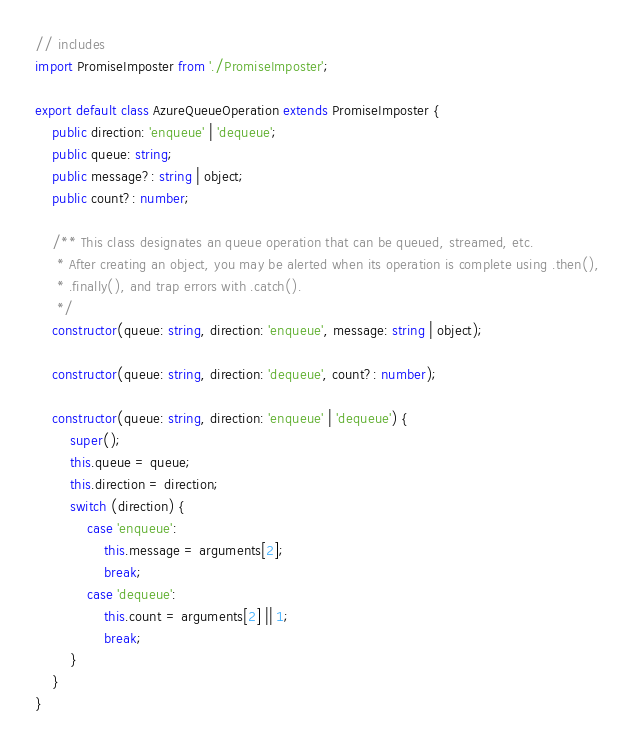<code> <loc_0><loc_0><loc_500><loc_500><_TypeScript_>// includes
import PromiseImposter from './PromiseImposter';

export default class AzureQueueOperation extends PromiseImposter {
    public direction: 'enqueue' | 'dequeue';
    public queue: string;
    public message?: string | object;
    public count?: number;

    /** This class designates an queue operation that can be queued, streamed, etc.
     * After creating an object, you may be alerted when its operation is complete using .then(),
     * .finally(), and trap errors with .catch().
     */
    constructor(queue: string, direction: 'enqueue', message: string | object);

    constructor(queue: string, direction: 'dequeue', count?: number);

    constructor(queue: string, direction: 'enqueue' | 'dequeue') {
        super();
        this.queue = queue;
        this.direction = direction;
        switch (direction) {
            case 'enqueue':
                this.message = arguments[2];
                break;
            case 'dequeue':
                this.count = arguments[2] || 1;
                break;
        }
    }
}
</code> 